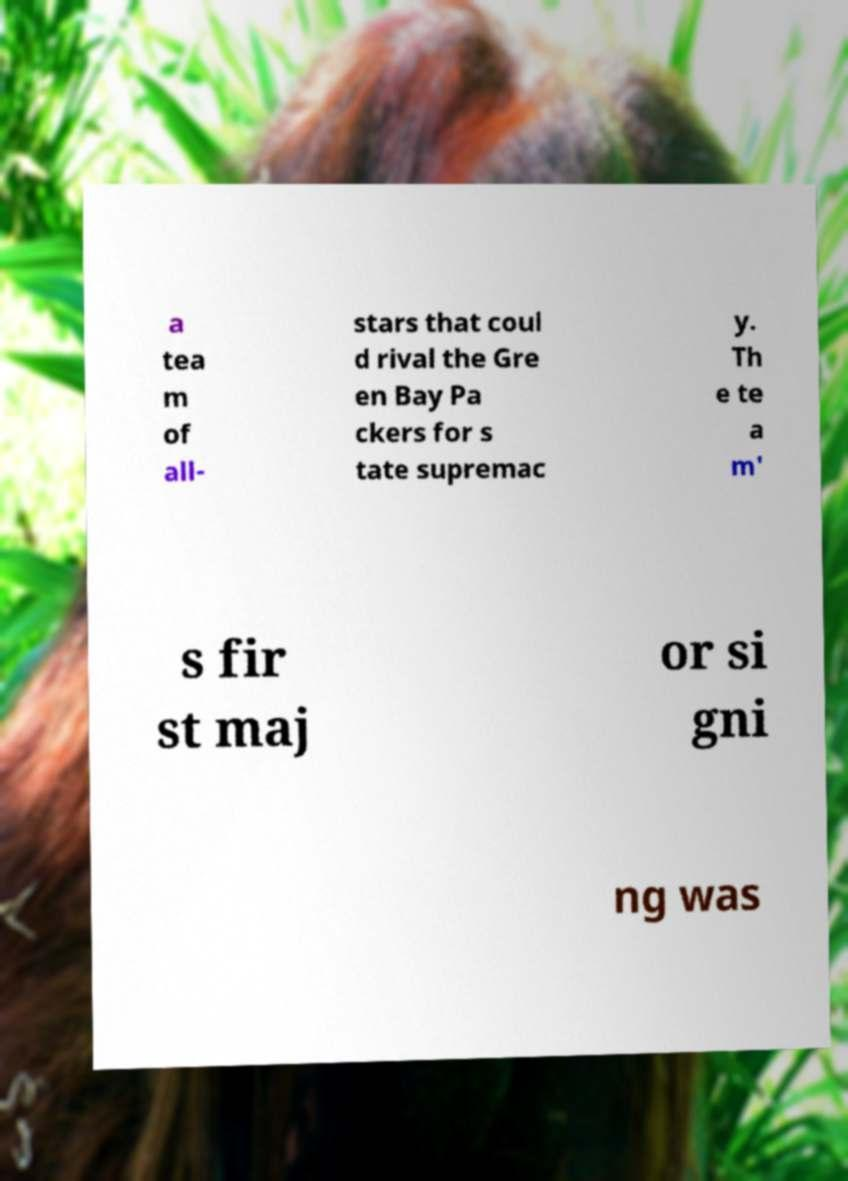Please read and relay the text visible in this image. What does it say? a tea m of all- stars that coul d rival the Gre en Bay Pa ckers for s tate supremac y. Th e te a m' s fir st maj or si gni ng was 